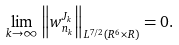Convert formula to latex. <formula><loc_0><loc_0><loc_500><loc_500>\lim _ { k \to \infty } \left \| w ^ { J _ { k } } _ { n _ { k } } \right \| _ { L ^ { 7 / 2 } ( R ^ { 6 } \times R ) } = 0 .</formula> 